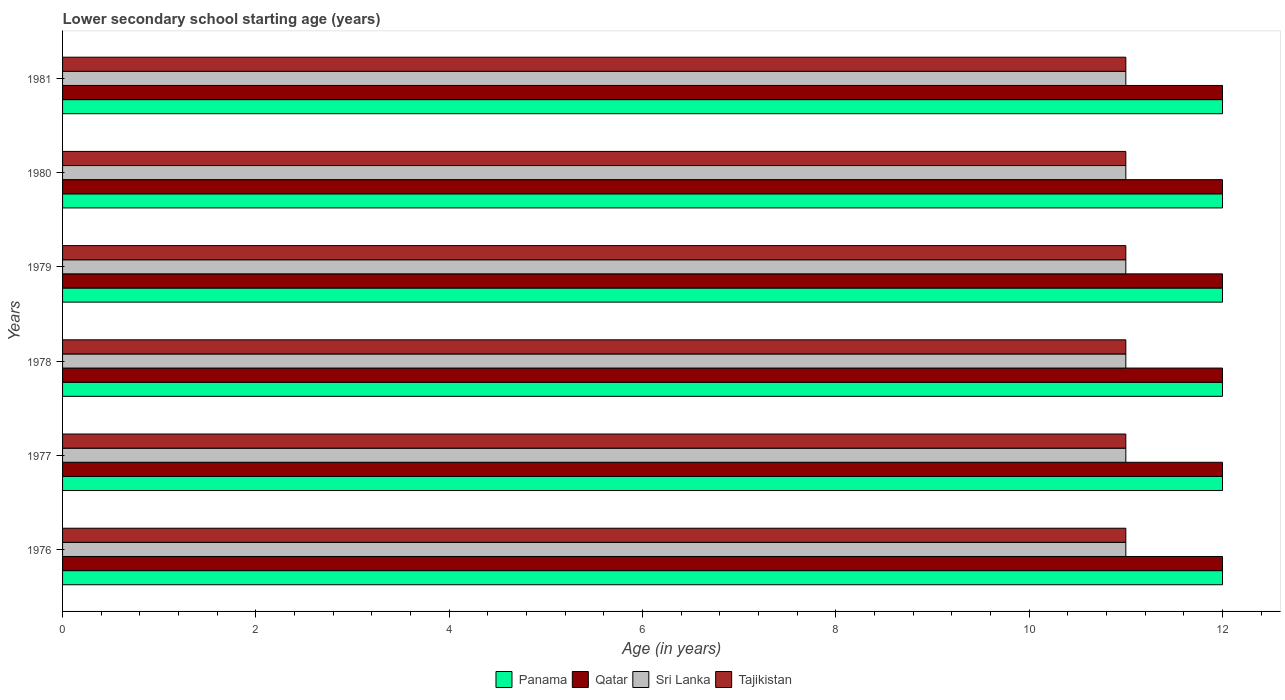What is the label of the 6th group of bars from the top?
Offer a very short reply. 1976. In how many cases, is the number of bars for a given year not equal to the number of legend labels?
Your response must be concise. 0. What is the lower secondary school starting age of children in Tajikistan in 1976?
Offer a very short reply. 11. Across all years, what is the maximum lower secondary school starting age of children in Qatar?
Ensure brevity in your answer.  12. Across all years, what is the minimum lower secondary school starting age of children in Panama?
Keep it short and to the point. 12. In which year was the lower secondary school starting age of children in Sri Lanka maximum?
Ensure brevity in your answer.  1976. In which year was the lower secondary school starting age of children in Sri Lanka minimum?
Your answer should be compact. 1976. What is the total lower secondary school starting age of children in Tajikistan in the graph?
Provide a succinct answer. 66. What is the difference between the lower secondary school starting age of children in Tajikistan in 1980 and the lower secondary school starting age of children in Sri Lanka in 1977?
Ensure brevity in your answer.  0. In the year 1976, what is the difference between the lower secondary school starting age of children in Sri Lanka and lower secondary school starting age of children in Qatar?
Your answer should be very brief. -1. What is the difference between the highest and the second highest lower secondary school starting age of children in Sri Lanka?
Make the answer very short. 0. In how many years, is the lower secondary school starting age of children in Sri Lanka greater than the average lower secondary school starting age of children in Sri Lanka taken over all years?
Provide a succinct answer. 0. What does the 3rd bar from the top in 1981 represents?
Your answer should be very brief. Qatar. What does the 3rd bar from the bottom in 1981 represents?
Your response must be concise. Sri Lanka. How many bars are there?
Provide a succinct answer. 24. Are the values on the major ticks of X-axis written in scientific E-notation?
Ensure brevity in your answer.  No. How many legend labels are there?
Provide a succinct answer. 4. What is the title of the graph?
Ensure brevity in your answer.  Lower secondary school starting age (years). What is the label or title of the X-axis?
Ensure brevity in your answer.  Age (in years). What is the Age (in years) in Qatar in 1976?
Provide a succinct answer. 12. What is the Age (in years) in Sri Lanka in 1976?
Your response must be concise. 11. What is the Age (in years) in Qatar in 1977?
Offer a terse response. 12. What is the Age (in years) in Tajikistan in 1977?
Provide a succinct answer. 11. What is the Age (in years) in Panama in 1978?
Offer a very short reply. 12. What is the Age (in years) in Sri Lanka in 1978?
Provide a succinct answer. 11. What is the Age (in years) in Qatar in 1979?
Offer a very short reply. 12. What is the Age (in years) of Panama in 1980?
Ensure brevity in your answer.  12. What is the Age (in years) of Panama in 1981?
Provide a short and direct response. 12. What is the Age (in years) in Tajikistan in 1981?
Your answer should be compact. 11. Across all years, what is the maximum Age (in years) of Panama?
Offer a terse response. 12. Across all years, what is the minimum Age (in years) of Panama?
Offer a very short reply. 12. Across all years, what is the minimum Age (in years) in Qatar?
Provide a succinct answer. 12. What is the total Age (in years) of Sri Lanka in the graph?
Offer a terse response. 66. What is the difference between the Age (in years) of Panama in 1976 and that in 1977?
Your answer should be compact. 0. What is the difference between the Age (in years) of Sri Lanka in 1976 and that in 1977?
Make the answer very short. 0. What is the difference between the Age (in years) in Tajikistan in 1976 and that in 1977?
Your answer should be very brief. 0. What is the difference between the Age (in years) of Sri Lanka in 1976 and that in 1978?
Give a very brief answer. 0. What is the difference between the Age (in years) of Tajikistan in 1976 and that in 1978?
Your answer should be very brief. 0. What is the difference between the Age (in years) of Panama in 1976 and that in 1979?
Your answer should be very brief. 0. What is the difference between the Age (in years) in Sri Lanka in 1976 and that in 1979?
Offer a very short reply. 0. What is the difference between the Age (in years) in Panama in 1976 and that in 1980?
Give a very brief answer. 0. What is the difference between the Age (in years) of Tajikistan in 1976 and that in 1980?
Provide a short and direct response. 0. What is the difference between the Age (in years) in Panama in 1976 and that in 1981?
Your answer should be very brief. 0. What is the difference between the Age (in years) of Qatar in 1976 and that in 1981?
Give a very brief answer. 0. What is the difference between the Age (in years) in Sri Lanka in 1976 and that in 1981?
Provide a short and direct response. 0. What is the difference between the Age (in years) in Tajikistan in 1976 and that in 1981?
Your response must be concise. 0. What is the difference between the Age (in years) of Panama in 1977 and that in 1978?
Offer a terse response. 0. What is the difference between the Age (in years) in Tajikistan in 1977 and that in 1978?
Keep it short and to the point. 0. What is the difference between the Age (in years) in Panama in 1977 and that in 1979?
Your response must be concise. 0. What is the difference between the Age (in years) of Qatar in 1977 and that in 1979?
Provide a short and direct response. 0. What is the difference between the Age (in years) in Tajikistan in 1977 and that in 1979?
Ensure brevity in your answer.  0. What is the difference between the Age (in years) in Panama in 1977 and that in 1980?
Provide a succinct answer. 0. What is the difference between the Age (in years) of Qatar in 1977 and that in 1980?
Provide a succinct answer. 0. What is the difference between the Age (in years) in Sri Lanka in 1977 and that in 1980?
Offer a very short reply. 0. What is the difference between the Age (in years) of Tajikistan in 1977 and that in 1980?
Offer a very short reply. 0. What is the difference between the Age (in years) in Qatar in 1977 and that in 1981?
Make the answer very short. 0. What is the difference between the Age (in years) of Sri Lanka in 1977 and that in 1981?
Offer a terse response. 0. What is the difference between the Age (in years) in Tajikistan in 1977 and that in 1981?
Offer a terse response. 0. What is the difference between the Age (in years) of Qatar in 1978 and that in 1979?
Your answer should be compact. 0. What is the difference between the Age (in years) of Sri Lanka in 1978 and that in 1979?
Offer a terse response. 0. What is the difference between the Age (in years) in Tajikistan in 1978 and that in 1979?
Provide a succinct answer. 0. What is the difference between the Age (in years) of Panama in 1978 and that in 1981?
Give a very brief answer. 0. What is the difference between the Age (in years) in Qatar in 1978 and that in 1981?
Offer a very short reply. 0. What is the difference between the Age (in years) of Sri Lanka in 1978 and that in 1981?
Make the answer very short. 0. What is the difference between the Age (in years) in Qatar in 1979 and that in 1981?
Make the answer very short. 0. What is the difference between the Age (in years) of Tajikistan in 1979 and that in 1981?
Your answer should be very brief. 0. What is the difference between the Age (in years) of Panama in 1980 and that in 1981?
Provide a short and direct response. 0. What is the difference between the Age (in years) in Qatar in 1980 and that in 1981?
Offer a very short reply. 0. What is the difference between the Age (in years) of Panama in 1976 and the Age (in years) of Qatar in 1977?
Your response must be concise. 0. What is the difference between the Age (in years) in Panama in 1976 and the Age (in years) in Tajikistan in 1977?
Make the answer very short. 1. What is the difference between the Age (in years) in Qatar in 1976 and the Age (in years) in Sri Lanka in 1977?
Ensure brevity in your answer.  1. What is the difference between the Age (in years) of Qatar in 1976 and the Age (in years) of Tajikistan in 1977?
Your response must be concise. 1. What is the difference between the Age (in years) in Panama in 1976 and the Age (in years) in Qatar in 1978?
Offer a very short reply. 0. What is the difference between the Age (in years) in Qatar in 1976 and the Age (in years) in Tajikistan in 1978?
Ensure brevity in your answer.  1. What is the difference between the Age (in years) in Sri Lanka in 1976 and the Age (in years) in Tajikistan in 1978?
Your answer should be compact. 0. What is the difference between the Age (in years) in Panama in 1976 and the Age (in years) in Qatar in 1979?
Keep it short and to the point. 0. What is the difference between the Age (in years) of Qatar in 1976 and the Age (in years) of Tajikistan in 1979?
Provide a succinct answer. 1. What is the difference between the Age (in years) of Panama in 1976 and the Age (in years) of Qatar in 1980?
Offer a terse response. 0. What is the difference between the Age (in years) in Panama in 1976 and the Age (in years) in Tajikistan in 1980?
Provide a short and direct response. 1. What is the difference between the Age (in years) of Panama in 1976 and the Age (in years) of Qatar in 1981?
Your answer should be very brief. 0. What is the difference between the Age (in years) of Sri Lanka in 1976 and the Age (in years) of Tajikistan in 1981?
Offer a very short reply. 0. What is the difference between the Age (in years) in Panama in 1977 and the Age (in years) in Tajikistan in 1978?
Make the answer very short. 1. What is the difference between the Age (in years) in Qatar in 1977 and the Age (in years) in Sri Lanka in 1978?
Give a very brief answer. 1. What is the difference between the Age (in years) of Sri Lanka in 1977 and the Age (in years) of Tajikistan in 1978?
Provide a short and direct response. 0. What is the difference between the Age (in years) in Panama in 1977 and the Age (in years) in Qatar in 1979?
Your answer should be compact. 0. What is the difference between the Age (in years) of Panama in 1977 and the Age (in years) of Tajikistan in 1979?
Keep it short and to the point. 1. What is the difference between the Age (in years) of Qatar in 1977 and the Age (in years) of Sri Lanka in 1979?
Provide a succinct answer. 1. What is the difference between the Age (in years) in Qatar in 1977 and the Age (in years) in Tajikistan in 1979?
Keep it short and to the point. 1. What is the difference between the Age (in years) of Sri Lanka in 1977 and the Age (in years) of Tajikistan in 1979?
Offer a very short reply. 0. What is the difference between the Age (in years) of Panama in 1977 and the Age (in years) of Qatar in 1980?
Give a very brief answer. 0. What is the difference between the Age (in years) of Panama in 1977 and the Age (in years) of Sri Lanka in 1980?
Provide a short and direct response. 1. What is the difference between the Age (in years) in Panama in 1977 and the Age (in years) in Tajikistan in 1980?
Your answer should be compact. 1. What is the difference between the Age (in years) in Qatar in 1977 and the Age (in years) in Sri Lanka in 1980?
Provide a succinct answer. 1. What is the difference between the Age (in years) of Qatar in 1977 and the Age (in years) of Tajikistan in 1980?
Your answer should be compact. 1. What is the difference between the Age (in years) of Sri Lanka in 1977 and the Age (in years) of Tajikistan in 1980?
Your response must be concise. 0. What is the difference between the Age (in years) of Panama in 1977 and the Age (in years) of Qatar in 1981?
Your answer should be very brief. 0. What is the difference between the Age (in years) in Panama in 1977 and the Age (in years) in Sri Lanka in 1981?
Your answer should be compact. 1. What is the difference between the Age (in years) in Qatar in 1977 and the Age (in years) in Sri Lanka in 1981?
Your answer should be compact. 1. What is the difference between the Age (in years) of Qatar in 1977 and the Age (in years) of Tajikistan in 1981?
Your answer should be very brief. 1. What is the difference between the Age (in years) in Sri Lanka in 1977 and the Age (in years) in Tajikistan in 1981?
Keep it short and to the point. 0. What is the difference between the Age (in years) of Panama in 1978 and the Age (in years) of Sri Lanka in 1979?
Provide a short and direct response. 1. What is the difference between the Age (in years) of Qatar in 1978 and the Age (in years) of Tajikistan in 1979?
Offer a terse response. 1. What is the difference between the Age (in years) in Panama in 1978 and the Age (in years) in Qatar in 1980?
Your answer should be compact. 0. What is the difference between the Age (in years) in Panama in 1978 and the Age (in years) in Sri Lanka in 1980?
Provide a short and direct response. 1. What is the difference between the Age (in years) of Qatar in 1978 and the Age (in years) of Sri Lanka in 1980?
Your response must be concise. 1. What is the difference between the Age (in years) of Panama in 1978 and the Age (in years) of Sri Lanka in 1981?
Keep it short and to the point. 1. What is the difference between the Age (in years) in Qatar in 1978 and the Age (in years) in Sri Lanka in 1981?
Provide a short and direct response. 1. What is the difference between the Age (in years) in Sri Lanka in 1978 and the Age (in years) in Tajikistan in 1981?
Give a very brief answer. 0. What is the difference between the Age (in years) in Panama in 1979 and the Age (in years) in Sri Lanka in 1980?
Ensure brevity in your answer.  1. What is the difference between the Age (in years) in Panama in 1979 and the Age (in years) in Tajikistan in 1980?
Offer a terse response. 1. What is the difference between the Age (in years) in Sri Lanka in 1979 and the Age (in years) in Tajikistan in 1980?
Your response must be concise. 0. What is the difference between the Age (in years) of Panama in 1979 and the Age (in years) of Qatar in 1981?
Make the answer very short. 0. What is the difference between the Age (in years) of Panama in 1979 and the Age (in years) of Sri Lanka in 1981?
Give a very brief answer. 1. What is the difference between the Age (in years) of Panama in 1980 and the Age (in years) of Sri Lanka in 1981?
Your answer should be compact. 1. What is the average Age (in years) of Panama per year?
Your response must be concise. 12. What is the average Age (in years) of Qatar per year?
Offer a very short reply. 12. What is the average Age (in years) in Sri Lanka per year?
Your answer should be very brief. 11. What is the average Age (in years) in Tajikistan per year?
Your answer should be very brief. 11. In the year 1976, what is the difference between the Age (in years) in Panama and Age (in years) in Sri Lanka?
Ensure brevity in your answer.  1. In the year 1976, what is the difference between the Age (in years) of Panama and Age (in years) of Tajikistan?
Make the answer very short. 1. In the year 1976, what is the difference between the Age (in years) of Sri Lanka and Age (in years) of Tajikistan?
Make the answer very short. 0. In the year 1977, what is the difference between the Age (in years) of Panama and Age (in years) of Sri Lanka?
Your answer should be very brief. 1. In the year 1977, what is the difference between the Age (in years) in Panama and Age (in years) in Tajikistan?
Ensure brevity in your answer.  1. In the year 1978, what is the difference between the Age (in years) in Panama and Age (in years) in Sri Lanka?
Make the answer very short. 1. In the year 1978, what is the difference between the Age (in years) of Qatar and Age (in years) of Sri Lanka?
Your answer should be very brief. 1. In the year 1979, what is the difference between the Age (in years) in Panama and Age (in years) in Qatar?
Make the answer very short. 0. In the year 1979, what is the difference between the Age (in years) of Panama and Age (in years) of Sri Lanka?
Offer a terse response. 1. In the year 1979, what is the difference between the Age (in years) of Panama and Age (in years) of Tajikistan?
Ensure brevity in your answer.  1. In the year 1979, what is the difference between the Age (in years) in Qatar and Age (in years) in Sri Lanka?
Offer a very short reply. 1. In the year 1980, what is the difference between the Age (in years) in Panama and Age (in years) in Qatar?
Your answer should be compact. 0. In the year 1980, what is the difference between the Age (in years) of Qatar and Age (in years) of Tajikistan?
Offer a terse response. 1. In the year 1980, what is the difference between the Age (in years) in Sri Lanka and Age (in years) in Tajikistan?
Ensure brevity in your answer.  0. In the year 1981, what is the difference between the Age (in years) of Panama and Age (in years) of Qatar?
Provide a short and direct response. 0. In the year 1981, what is the difference between the Age (in years) of Qatar and Age (in years) of Sri Lanka?
Offer a terse response. 1. In the year 1981, what is the difference between the Age (in years) of Sri Lanka and Age (in years) of Tajikistan?
Offer a terse response. 0. What is the ratio of the Age (in years) in Tajikistan in 1976 to that in 1977?
Offer a terse response. 1. What is the ratio of the Age (in years) in Panama in 1976 to that in 1978?
Keep it short and to the point. 1. What is the ratio of the Age (in years) in Sri Lanka in 1976 to that in 1978?
Offer a terse response. 1. What is the ratio of the Age (in years) of Panama in 1976 to that in 1979?
Keep it short and to the point. 1. What is the ratio of the Age (in years) in Sri Lanka in 1976 to that in 1979?
Provide a short and direct response. 1. What is the ratio of the Age (in years) of Panama in 1976 to that in 1980?
Keep it short and to the point. 1. What is the ratio of the Age (in years) of Panama in 1976 to that in 1981?
Give a very brief answer. 1. What is the ratio of the Age (in years) of Sri Lanka in 1976 to that in 1981?
Offer a terse response. 1. What is the ratio of the Age (in years) of Panama in 1977 to that in 1978?
Provide a succinct answer. 1. What is the ratio of the Age (in years) of Qatar in 1977 to that in 1979?
Keep it short and to the point. 1. What is the ratio of the Age (in years) of Tajikistan in 1977 to that in 1979?
Make the answer very short. 1. What is the ratio of the Age (in years) in Panama in 1977 to that in 1980?
Provide a short and direct response. 1. What is the ratio of the Age (in years) of Tajikistan in 1977 to that in 1980?
Your answer should be compact. 1. What is the ratio of the Age (in years) in Sri Lanka in 1977 to that in 1981?
Give a very brief answer. 1. What is the ratio of the Age (in years) in Qatar in 1978 to that in 1979?
Keep it short and to the point. 1. What is the ratio of the Age (in years) in Sri Lanka in 1978 to that in 1979?
Your answer should be compact. 1. What is the ratio of the Age (in years) in Qatar in 1978 to that in 1980?
Your response must be concise. 1. What is the ratio of the Age (in years) in Tajikistan in 1978 to that in 1980?
Provide a short and direct response. 1. What is the ratio of the Age (in years) in Panama in 1978 to that in 1981?
Your response must be concise. 1. What is the ratio of the Age (in years) of Sri Lanka in 1978 to that in 1981?
Make the answer very short. 1. What is the ratio of the Age (in years) of Qatar in 1979 to that in 1980?
Offer a very short reply. 1. What is the ratio of the Age (in years) in Sri Lanka in 1979 to that in 1980?
Provide a short and direct response. 1. What is the ratio of the Age (in years) of Tajikistan in 1979 to that in 1980?
Make the answer very short. 1. What is the ratio of the Age (in years) in Qatar in 1979 to that in 1981?
Ensure brevity in your answer.  1. What is the ratio of the Age (in years) in Sri Lanka in 1979 to that in 1981?
Make the answer very short. 1. What is the ratio of the Age (in years) in Tajikistan in 1979 to that in 1981?
Your answer should be compact. 1. What is the ratio of the Age (in years) of Panama in 1980 to that in 1981?
Provide a short and direct response. 1. What is the ratio of the Age (in years) of Qatar in 1980 to that in 1981?
Make the answer very short. 1. What is the ratio of the Age (in years) of Sri Lanka in 1980 to that in 1981?
Make the answer very short. 1. What is the ratio of the Age (in years) of Tajikistan in 1980 to that in 1981?
Give a very brief answer. 1. What is the difference between the highest and the second highest Age (in years) of Sri Lanka?
Keep it short and to the point. 0. What is the difference between the highest and the second highest Age (in years) of Tajikistan?
Make the answer very short. 0. What is the difference between the highest and the lowest Age (in years) of Panama?
Offer a very short reply. 0. What is the difference between the highest and the lowest Age (in years) of Qatar?
Offer a terse response. 0. What is the difference between the highest and the lowest Age (in years) of Sri Lanka?
Provide a succinct answer. 0. 